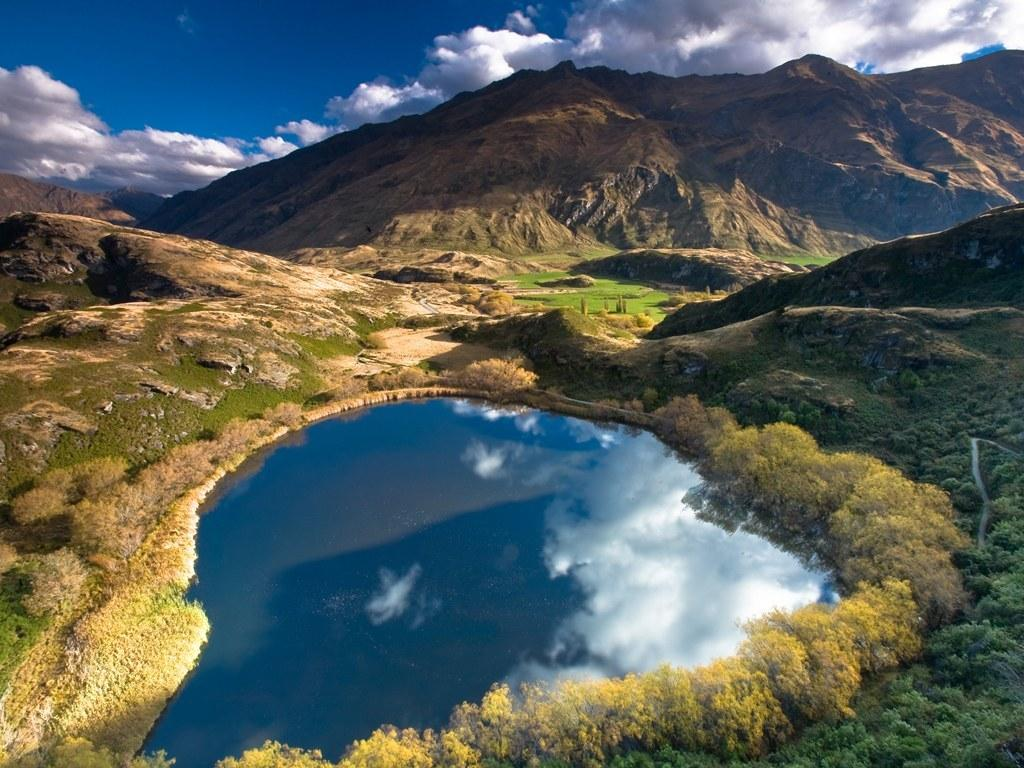What is the condition of the sky in the image? The sky is cloudy in the image. What type of vegetation can be seen in the image? There are plants and grass in the image. What is the body of water in the image? There is water in the image. How does the sky's condition affect the water in the image? The clouds are reflected in the water in the image. What type of pickle is floating in the water in the image? There is no pickle present in the image; it features plants, grass, water, and a cloudy sky. 